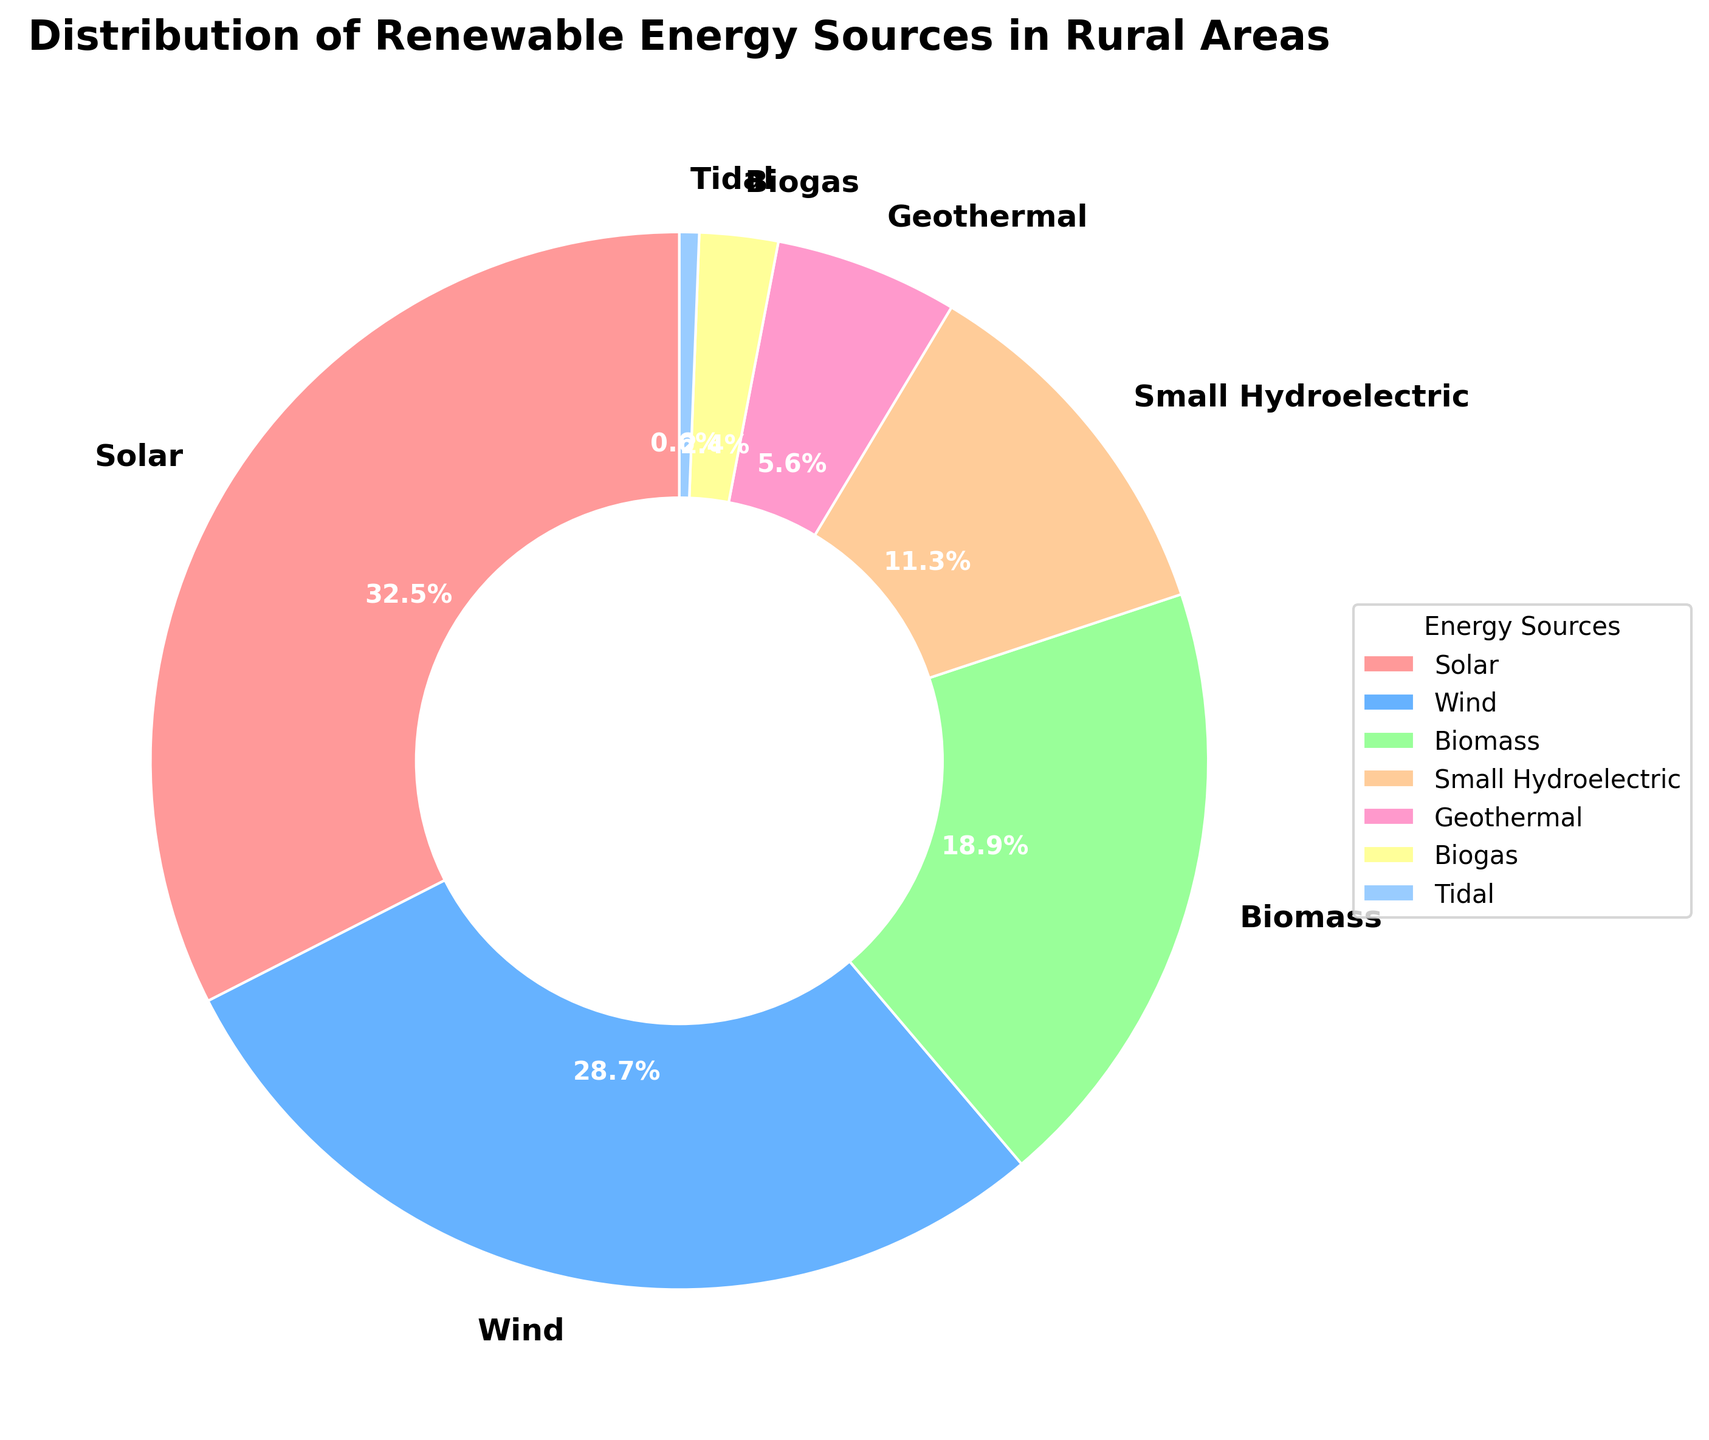What is the renewable energy source with the highest distribution percentage? Looking at the pie chart, the largest slice corresponds to the renewable energy source labeled Solar, with a percentage of 32.5%. This indicates that Solar has the highest distribution among the listed energy sources.
Answer: Solar What is the combined distribution percentage of Wind and Biomass energy sources? The percentage for Wind is 28.7%, and for Biomass, it is 18.9%. Adding these together gives 28.7 + 18.9 = 47.6%.
Answer: 47.6% Which renewable energy source has the smallest distribution percentage? Observing the pie chart, the smallest slice corresponds to Tidal energy, which has a percentage of 0.6%.
Answer: Tidal Is the distribution percentage of Small Hydroelectric energy greater than Biogas energy? The percentage for Small Hydroelectric is 11.3%, and for Biogas, it is 2.4%. Since 11.3% is greater than 2.4%, Small Hydroelectric has a greater distribution percentage than Biogas.
Answer: Yes Which two renewable energy sources have distribution percentages that sum up to more than 60%? By examining the chart, we see that Solar (32.5%) and Wind (28.7%) are the top two sources. Adding their percentages, we get 32.5 + 28.7 = 61.2%, which is more than 60%.
Answer: Solar and Wind What is the percentage difference between Solar and Wind energy sources? The percentage for Solar is 32.5% and for Wind, it is 28.7%. The difference between these two is calculated as 32.5 - 28.7 = 3.8%.
Answer: 3.8% If we combine the distribution percentages of Biomass, Small Hydroelectric, and Geothermal, do they collectively have a higher distribution percentage than Solar? Summing the percentages of Biomass (18.9%), Small Hydroelectric (11.3%), and Geothermal (5.6%) gives 18.9 + 11.3 + 5.6 = 35.8%. Since 35.8% is greater than Solar's 32.5%, the combined percentage is indeed higher.
Answer: Yes Which energy sources have a distribution percentage below 10%? Observing the chart, the energy sources with percentages below 10% are Geothermal with 5.6%, Biogas with 2.4%, and Tidal with 0.6%.
Answer: Geothermal, Biogas, Tidal What is the combined percentage of all energy sources except Solar? Summing all the percentages except Solar: Wind (28.7%), Biomass (18.9%), Small Hydroelectric (11.3%), Geothermal (5.6%), Biogas (2.4%), Tidal (0.6%). The total is 28.7 + 18.9 + 11.3 + 5.6 + 2.4 + 0.6 = 67.5%.
Answer: 67.5% 